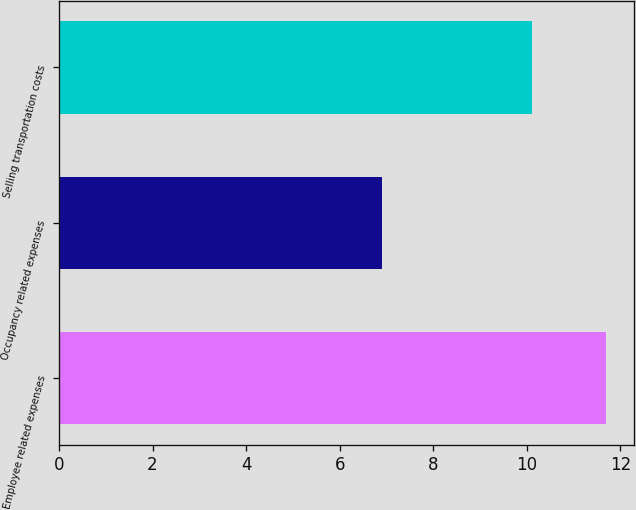Convert chart to OTSL. <chart><loc_0><loc_0><loc_500><loc_500><bar_chart><fcel>Employee related expenses<fcel>Occupancy related expenses<fcel>Selling transportation costs<nl><fcel>11.7<fcel>6.9<fcel>10.1<nl></chart> 